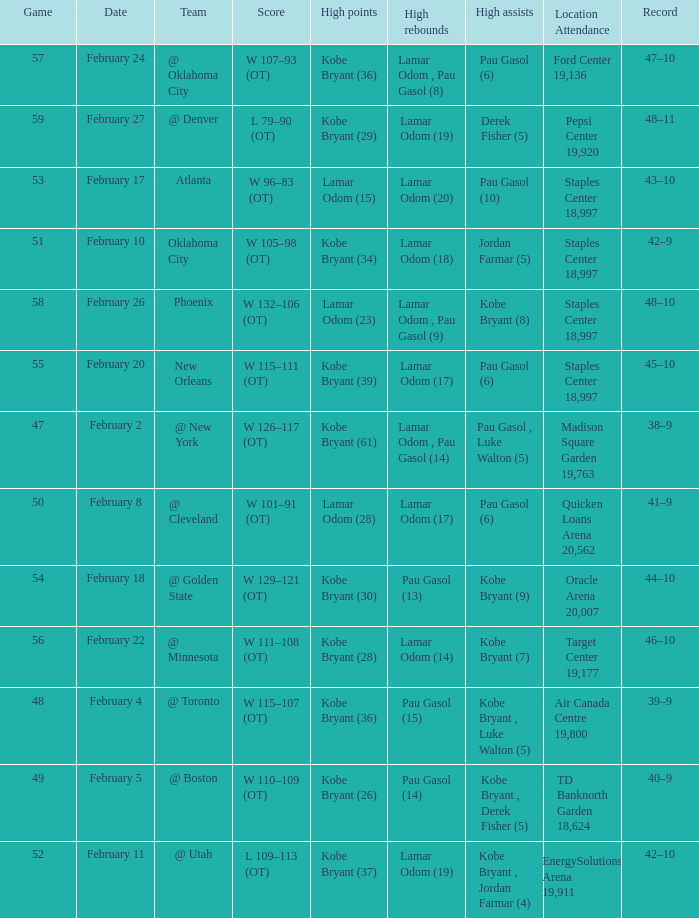Who had the most assists in the game against Atlanta? Pau Gasol (10). 